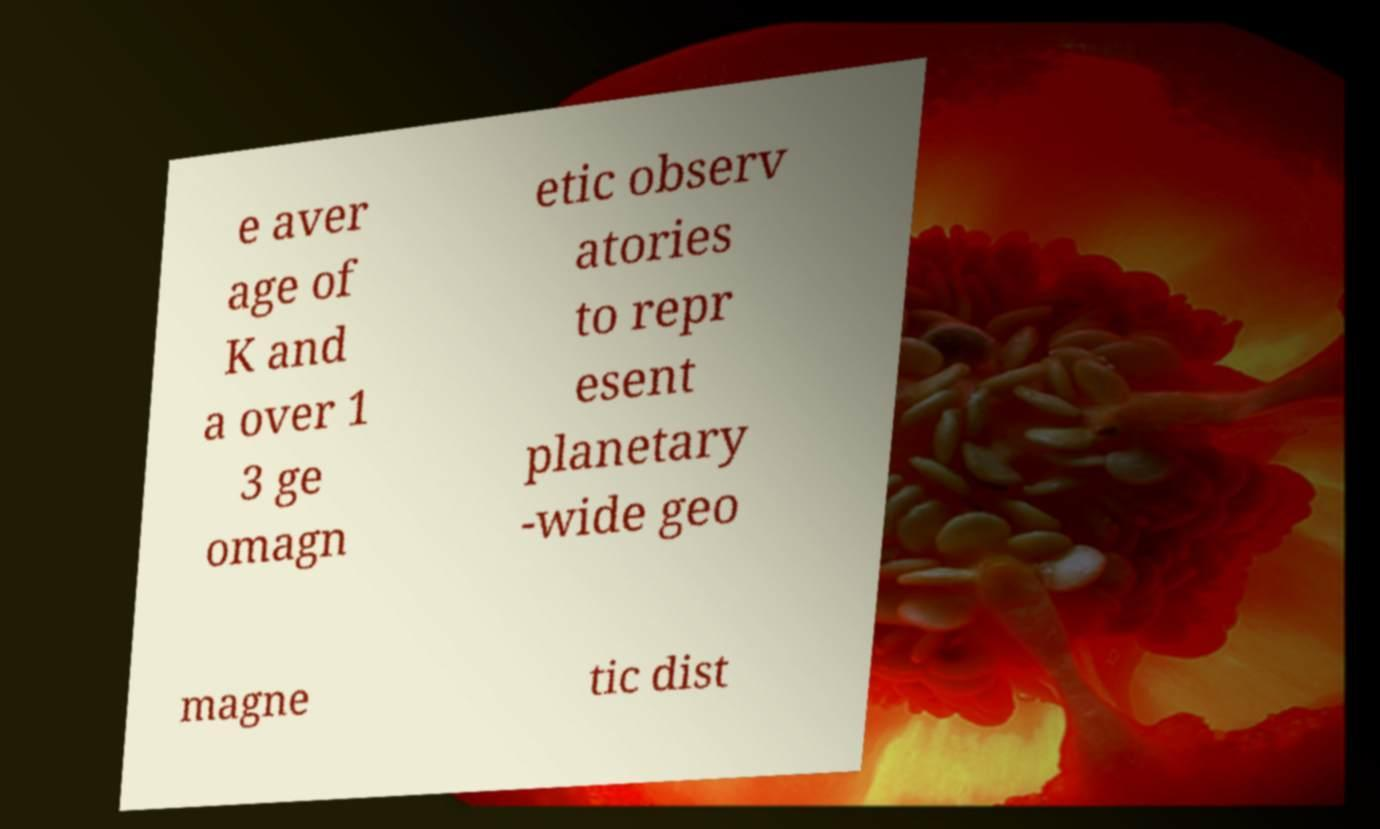Could you extract and type out the text from this image? e aver age of K and a over 1 3 ge omagn etic observ atories to repr esent planetary -wide geo magne tic dist 